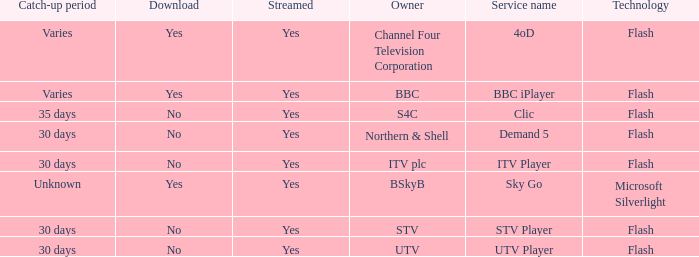What is the catch-up duration for utv? 30 days. 